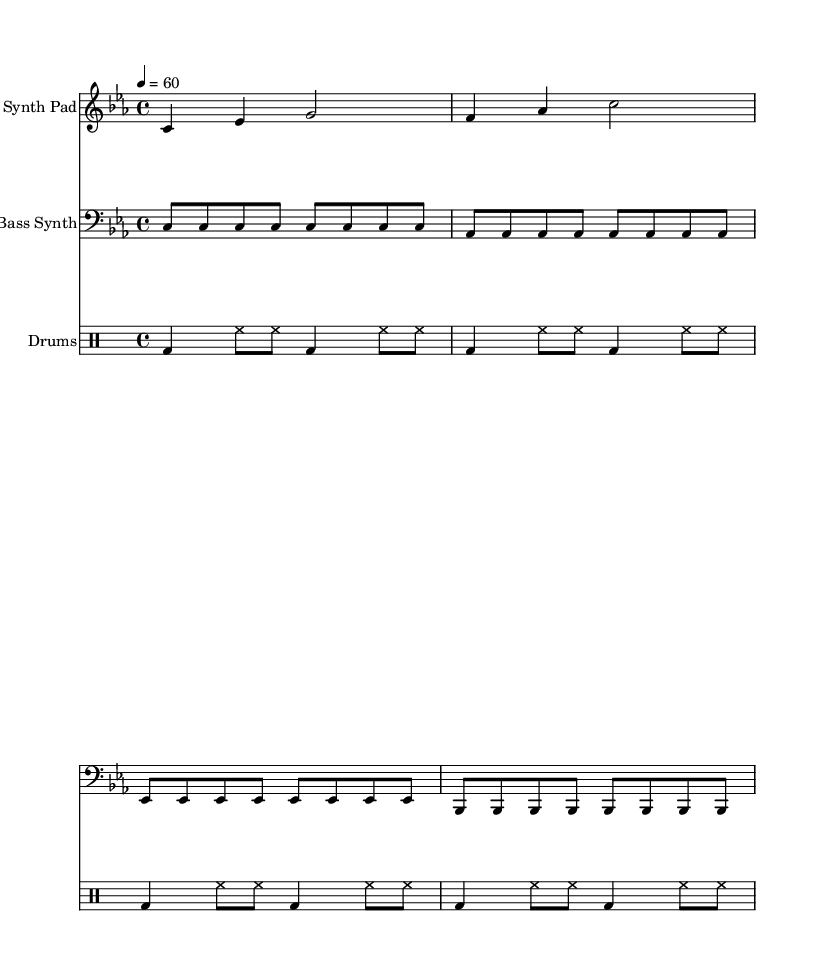What is the key signature of this music? The key signature shown in the music is C minor, which has three flats (B♭, E♭, and A♭). This is determined by the presence of flats in the key signature area at the beginning of the staff.
Answer: C minor What is the time signature of this music? The time signature indicated in the music is 4/4, which allows for four beats per measure with a quarter note receiving one beat. This is visible at the beginning of the score.
Answer: 4/4 What is the tempo marking of this music? The tempo marking given in the music is "4 = 60", indicating that a quarter note is played at a speed of 60 beats per minute. This can be found near the start of the score.
Answer: 60 How many measures are there in the main theme? The main theme section consists of four measures, each separated by bar lines. By counting the segments from the start to the end of the melody, I conclude there are four distinct measures.
Answer: 4 What instrument is associated with the bass synth? The bass synth is indicated as "Bass Synth" in the label above the staff where the bass notes are written. This label clearly identifies the instrument playing those notes.
Answer: Bass Synth What rhythmic pattern does the drums part follow? The drums part utilizes a repeating rhythmic pattern consisting of bass drums on beats 1 and 3, with hi-hats consistently played in between. By analyzing the drummode section, one can see the alternating structure of bass and hi-hat notes.
Answer: Repeating pattern 